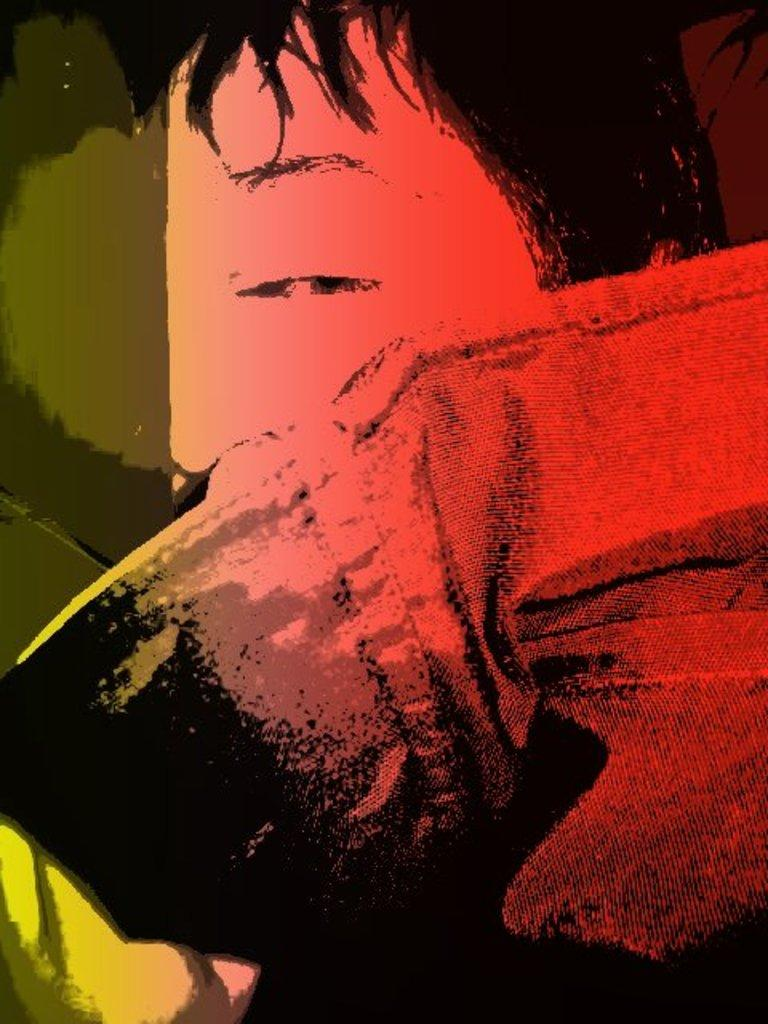What is depicted in the image? There is a painting of a man in the image. Can you describe the man in the painting? Unfortunately, the provided facts do not include any details about the man's appearance or the style of the painting. What emotions or expressions might the man in the painting be conveying? Again, the provided facts do not include any information about the man's emotions or expressions. What type of celery is being used as a brush in the painting? There is no mention of celery or any other unconventional painting tools in the provided facts. 